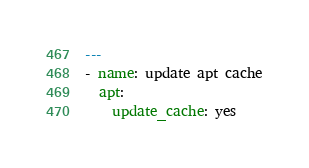<code> <loc_0><loc_0><loc_500><loc_500><_YAML_>---
- name: update apt cache
  apt:
    update_cache: yes
</code> 